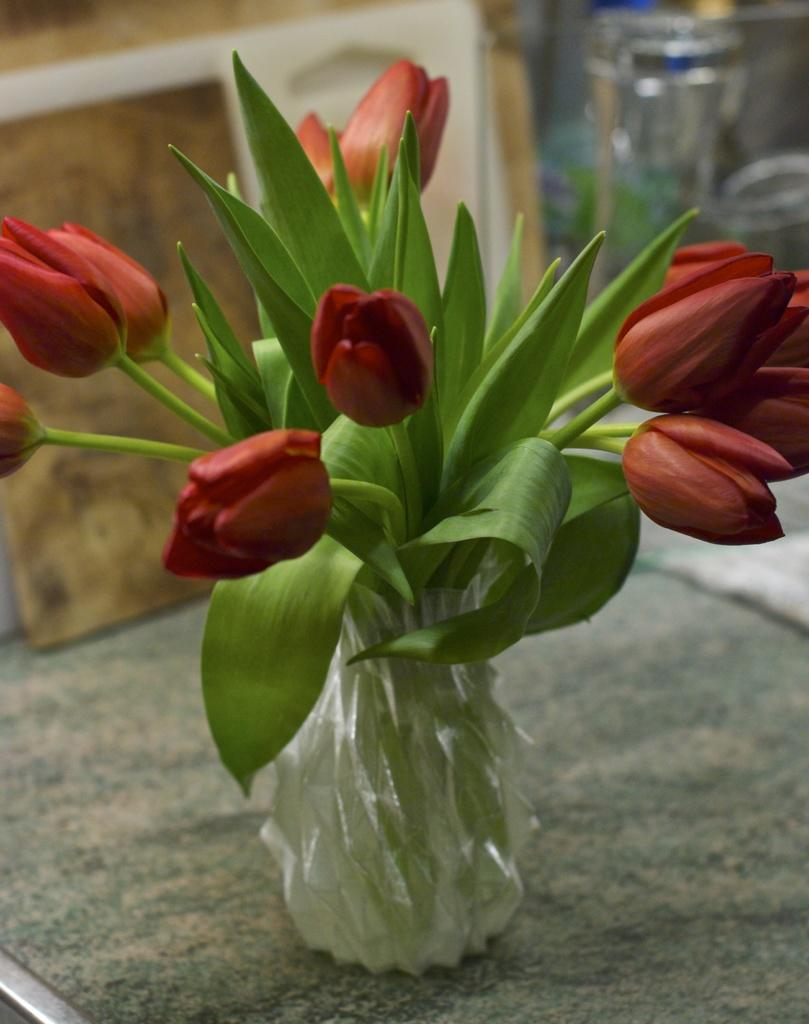What is the main object in the image? There is a flower vase in the image. What type of flower is in the vase? A tulip flower plant is kept inside the vase. How many tulip flowers are on the plant? There are tulip flowers on the plant. What can be observed about the background of the flowers? The background of the flowers is blurred. What type of match can be seen being used to light the oil in the image? There is no match or oil present in the image; it features a flower vase with a tulip flower plant. What arithmetic problem is being solved by the flowers in the image? There is no arithmetic problem being solved by the flowers in the image; they are simply tulip flowers in a vase. 